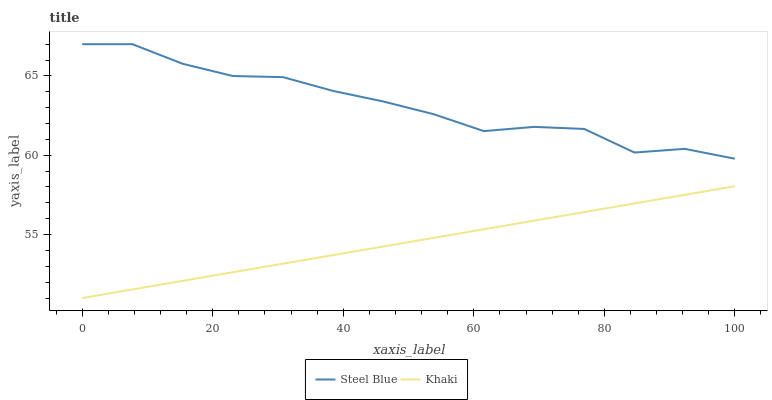Does Khaki have the minimum area under the curve?
Answer yes or no. Yes. Does Steel Blue have the maximum area under the curve?
Answer yes or no. Yes. Does Steel Blue have the minimum area under the curve?
Answer yes or no. No. Is Khaki the smoothest?
Answer yes or no. Yes. Is Steel Blue the roughest?
Answer yes or no. Yes. Is Steel Blue the smoothest?
Answer yes or no. No. Does Khaki have the lowest value?
Answer yes or no. Yes. Does Steel Blue have the lowest value?
Answer yes or no. No. Does Steel Blue have the highest value?
Answer yes or no. Yes. Is Khaki less than Steel Blue?
Answer yes or no. Yes. Is Steel Blue greater than Khaki?
Answer yes or no. Yes. Does Khaki intersect Steel Blue?
Answer yes or no. No. 